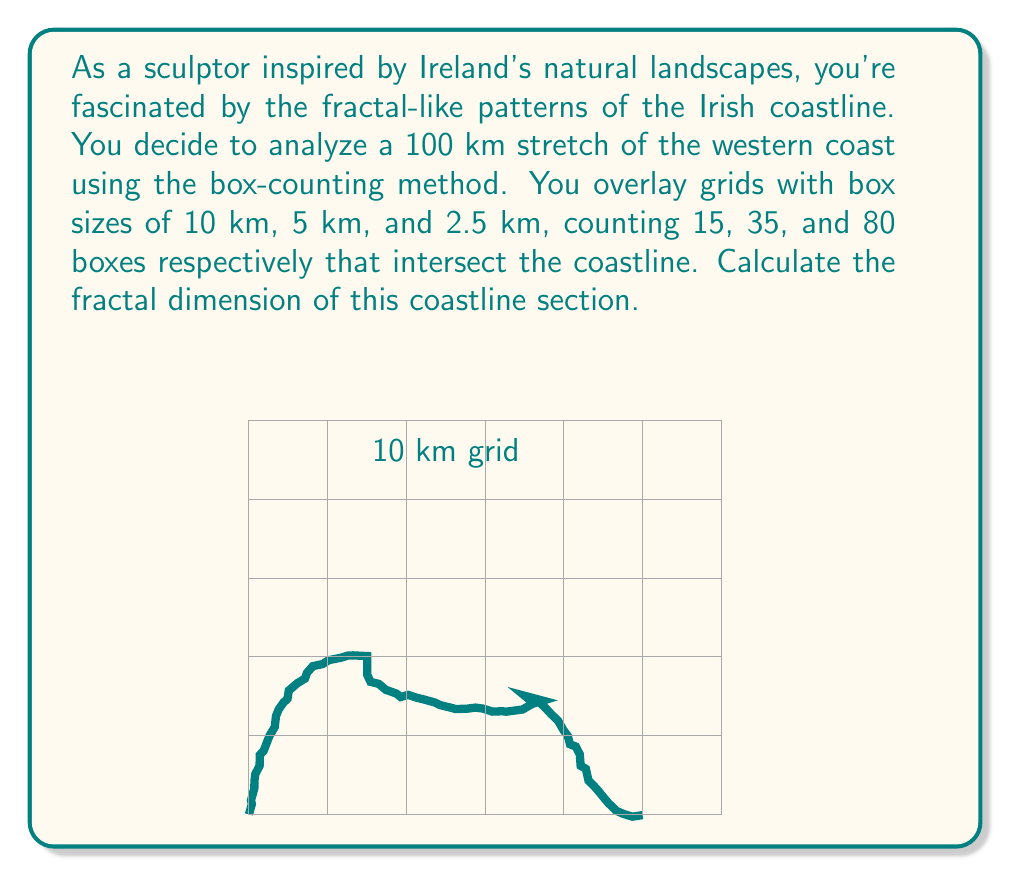Help me with this question. To calculate the fractal dimension using the box-counting method, we use the formula:

$$D = \frac{\log(N_2/N_1)}{\log(r_1/r_2)}$$

Where:
$D$ is the fractal dimension
$N_1$ and $N_2$ are the number of boxes counted at two different scales
$r_1$ and $r_2$ are the corresponding box sizes

Let's calculate $D$ using the given data:

1) For 10 km and 5 km boxes:
   $N_1 = 15$, $N_2 = 35$, $r_1 = 10$, $r_2 = 5$
   
   $$D_{10-5} = \frac{\log(35/15)}{\log(10/5)} = \frac{\log(2.333)}{\log(2)} = 1.222$$

2) For 5 km and 2.5 km boxes:
   $N_1 = 35$, $N_2 = 80$, $r_1 = 5$, $r_2 = 2.5$
   
   $$D_{5-2.5} = \frac{\log(80/35)}{\log(5/2.5)} = \frac{\log(2.286)}{\log(2)} = 1.193$$

3) For 10 km and 2.5 km boxes:
   $N_1 = 15$, $N_2 = 80$, $r_1 = 10$, $r_2 = 2.5$
   
   $$D_{10-2.5} = \frac{\log(80/15)}{\log(10/2.5)} = \frac{\log(5.333)}{\log(4)} = 1.207$$

The fractal dimension is the average of these three calculations:

$$D = \frac{1.222 + 1.193 + 1.207}{3} = 1.207$$

This value between 1 and 2 indicates that the coastline has fractal-like properties, being more complex than a simple line (dimension 1) but not filling a plane (dimension 2).
Answer: $D \approx 1.207$ 